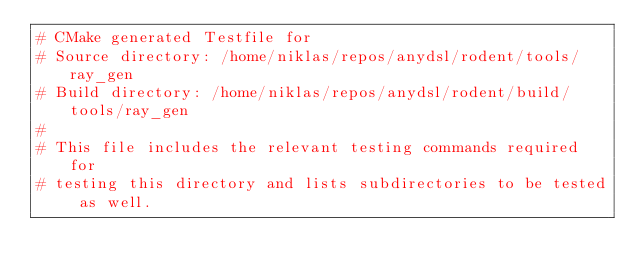Convert code to text. <code><loc_0><loc_0><loc_500><loc_500><_CMake_># CMake generated Testfile for 
# Source directory: /home/niklas/repos/anydsl/rodent/tools/ray_gen
# Build directory: /home/niklas/repos/anydsl/rodent/build/tools/ray_gen
# 
# This file includes the relevant testing commands required for 
# testing this directory and lists subdirectories to be tested as well.
</code> 